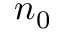<formula> <loc_0><loc_0><loc_500><loc_500>n _ { 0 }</formula> 